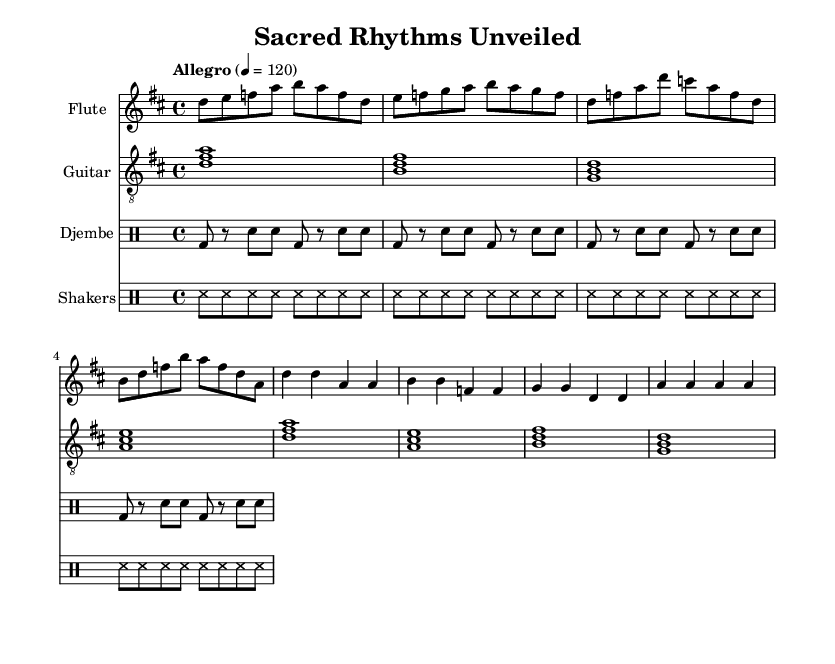What is the key signature of this music? The key signature is indicated by the sharp symbols on the staff. In this case, there are two sharps, which correspond to F# and C#. Therefore, the key signature is D major, which contains these sharps.
Answer: D major What is the time signature of this music? The time signature is displayed at the beginning of the score, shown as the fraction 4/4. This indicates that there are four beats in each measure and the quarter note gets one beat.
Answer: 4/4 What is the tempo marking for this music? The tempo marking is located at the beginning of the score and it says "Allegro" followed by a metronome marking of 4 = 120. This indicates a lively and fast tempo at a speed of 120 beats per minute.
Answer: Allegro, 4 = 120 How many instruments are featured in the score? The score consists of four staves, each designated for a different instrument: flute, guitar, djembe, and shakers. Counting these gives the total number of instruments present in the music.
Answer: Four What is the rhythmic pattern shown in the djembe part? The djembe part presents a repeating pattern where the bass drum (bd) is played followed by rests (r) and snare hits (sn). By analyzing the notated rhythms, the basic rhythm pattern consists of a series of bass and snare hits alternating with rests.
Answer: Bass and snare What type of music does this composition represent? By analyzing the instrumentation and the upbeat nature of the tempo, along with the incorporation of elements from various cultural traditions, this composition represents dance music that is influenced by world music, showcasing diverse cultural ceremonies.
Answer: Dance 